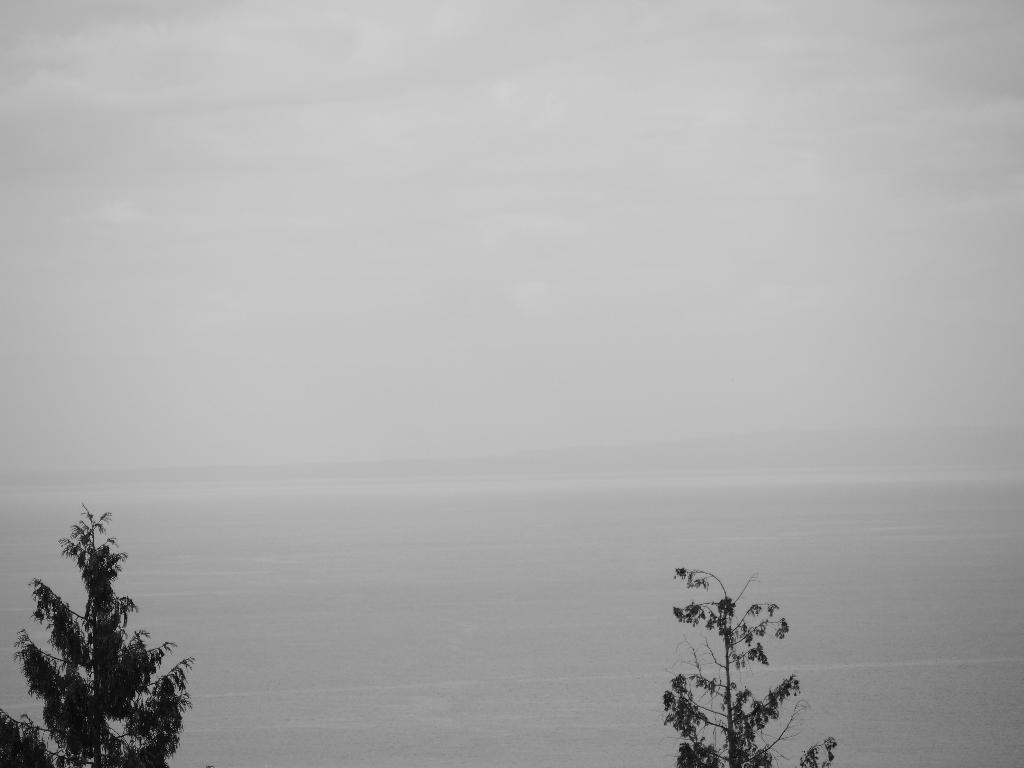How would you summarize this image in a sentence or two? In this picture, we can see trees, and we can see the background. 